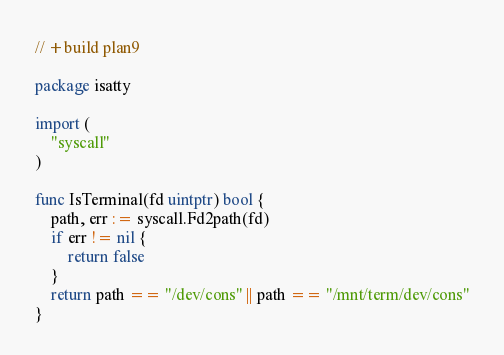Convert code to text. <code><loc_0><loc_0><loc_500><loc_500><_Go_>// +build plan9

package isatty

import (
	"syscall"
)

func IsTerminal(fd uintptr) bool {
	path, err := syscall.Fd2path(fd)
	if err != nil {
		return false
	}
	return path == "/dev/cons" || path == "/mnt/term/dev/cons"
}
</code> 